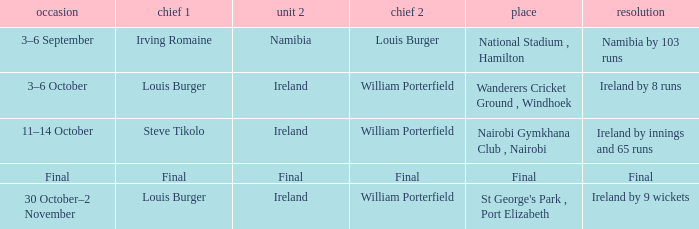Which Captain 2 has a Result of final? Final. Help me parse the entirety of this table. {'header': ['occasion', 'chief 1', 'unit 2', 'chief 2', 'place', 'resolution'], 'rows': [['3–6 September', 'Irving Romaine', 'Namibia', 'Louis Burger', 'National Stadium , Hamilton', 'Namibia by 103 runs'], ['3–6 October', 'Louis Burger', 'Ireland', 'William Porterfield', 'Wanderers Cricket Ground , Windhoek', 'Ireland by 8 runs'], ['11–14 October', 'Steve Tikolo', 'Ireland', 'William Porterfield', 'Nairobi Gymkhana Club , Nairobi', 'Ireland by innings and 65 runs'], ['Final', 'Final', 'Final', 'Final', 'Final', 'Final'], ['30 October–2 November', 'Louis Burger', 'Ireland', 'William Porterfield', "St George's Park , Port Elizabeth", 'Ireland by 9 wickets']]} 